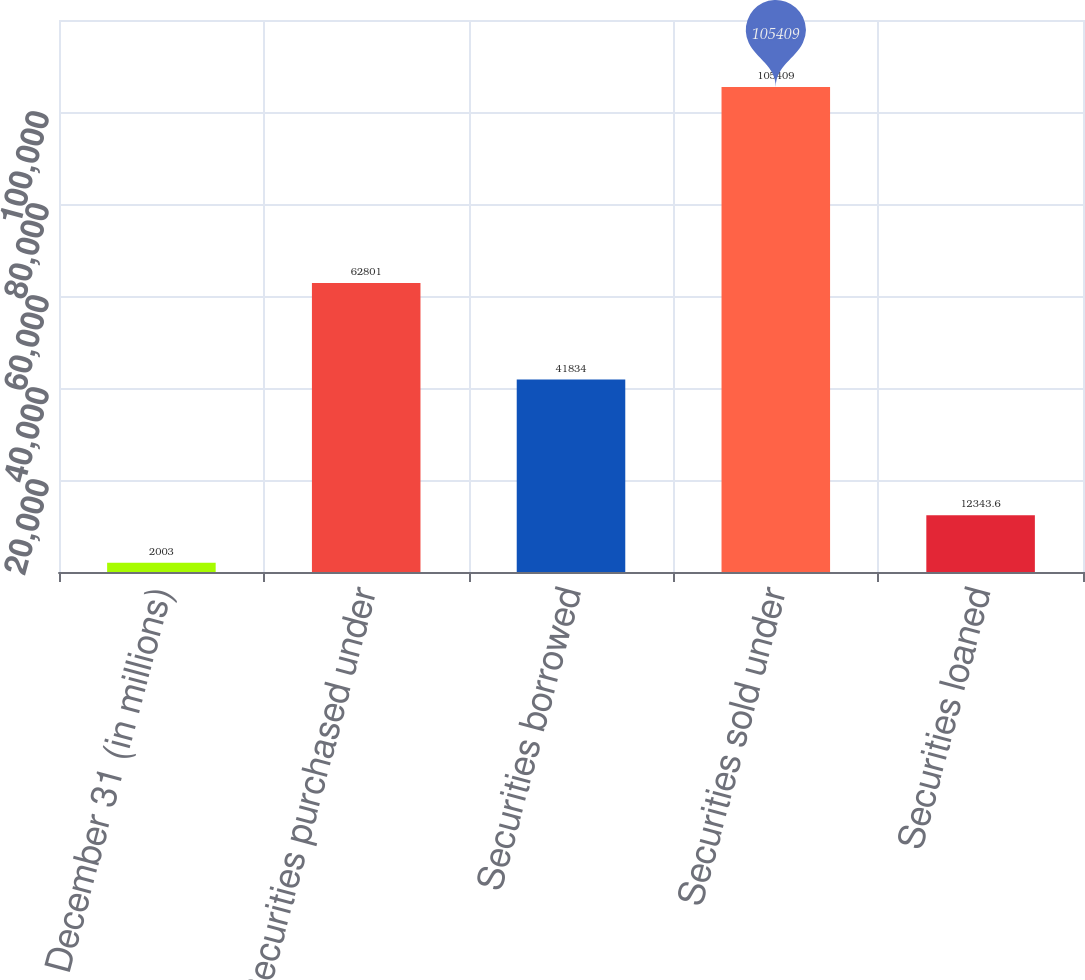<chart> <loc_0><loc_0><loc_500><loc_500><bar_chart><fcel>December 31 (in millions)<fcel>Securities purchased under<fcel>Securities borrowed<fcel>Securities sold under<fcel>Securities loaned<nl><fcel>2003<fcel>62801<fcel>41834<fcel>105409<fcel>12343.6<nl></chart> 